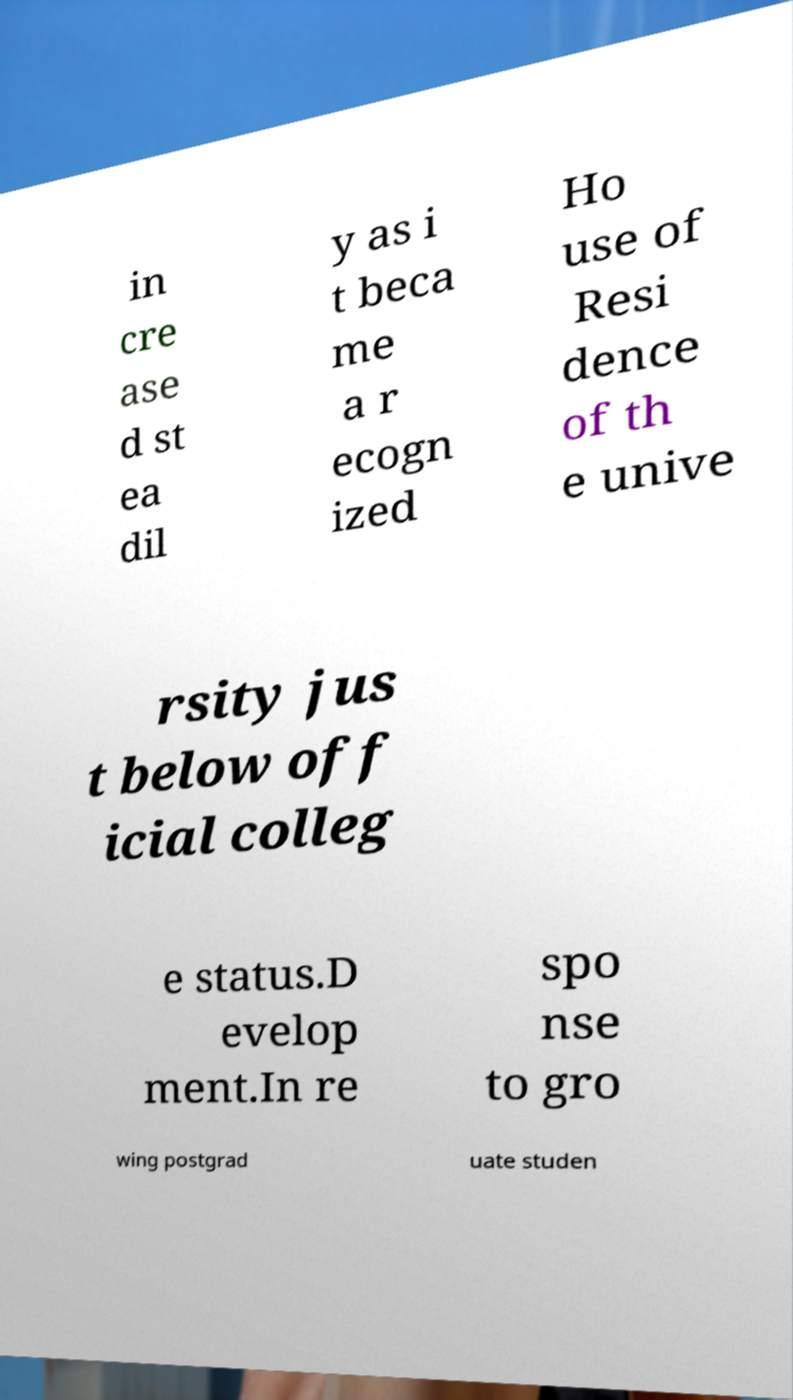Please read and relay the text visible in this image. What does it say? in cre ase d st ea dil y as i t beca me a r ecogn ized Ho use of Resi dence of th e unive rsity jus t below off icial colleg e status.D evelop ment.In re spo nse to gro wing postgrad uate studen 